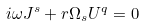<formula> <loc_0><loc_0><loc_500><loc_500>i \omega J ^ { s } + r \Omega _ { s } U ^ { q } = 0</formula> 